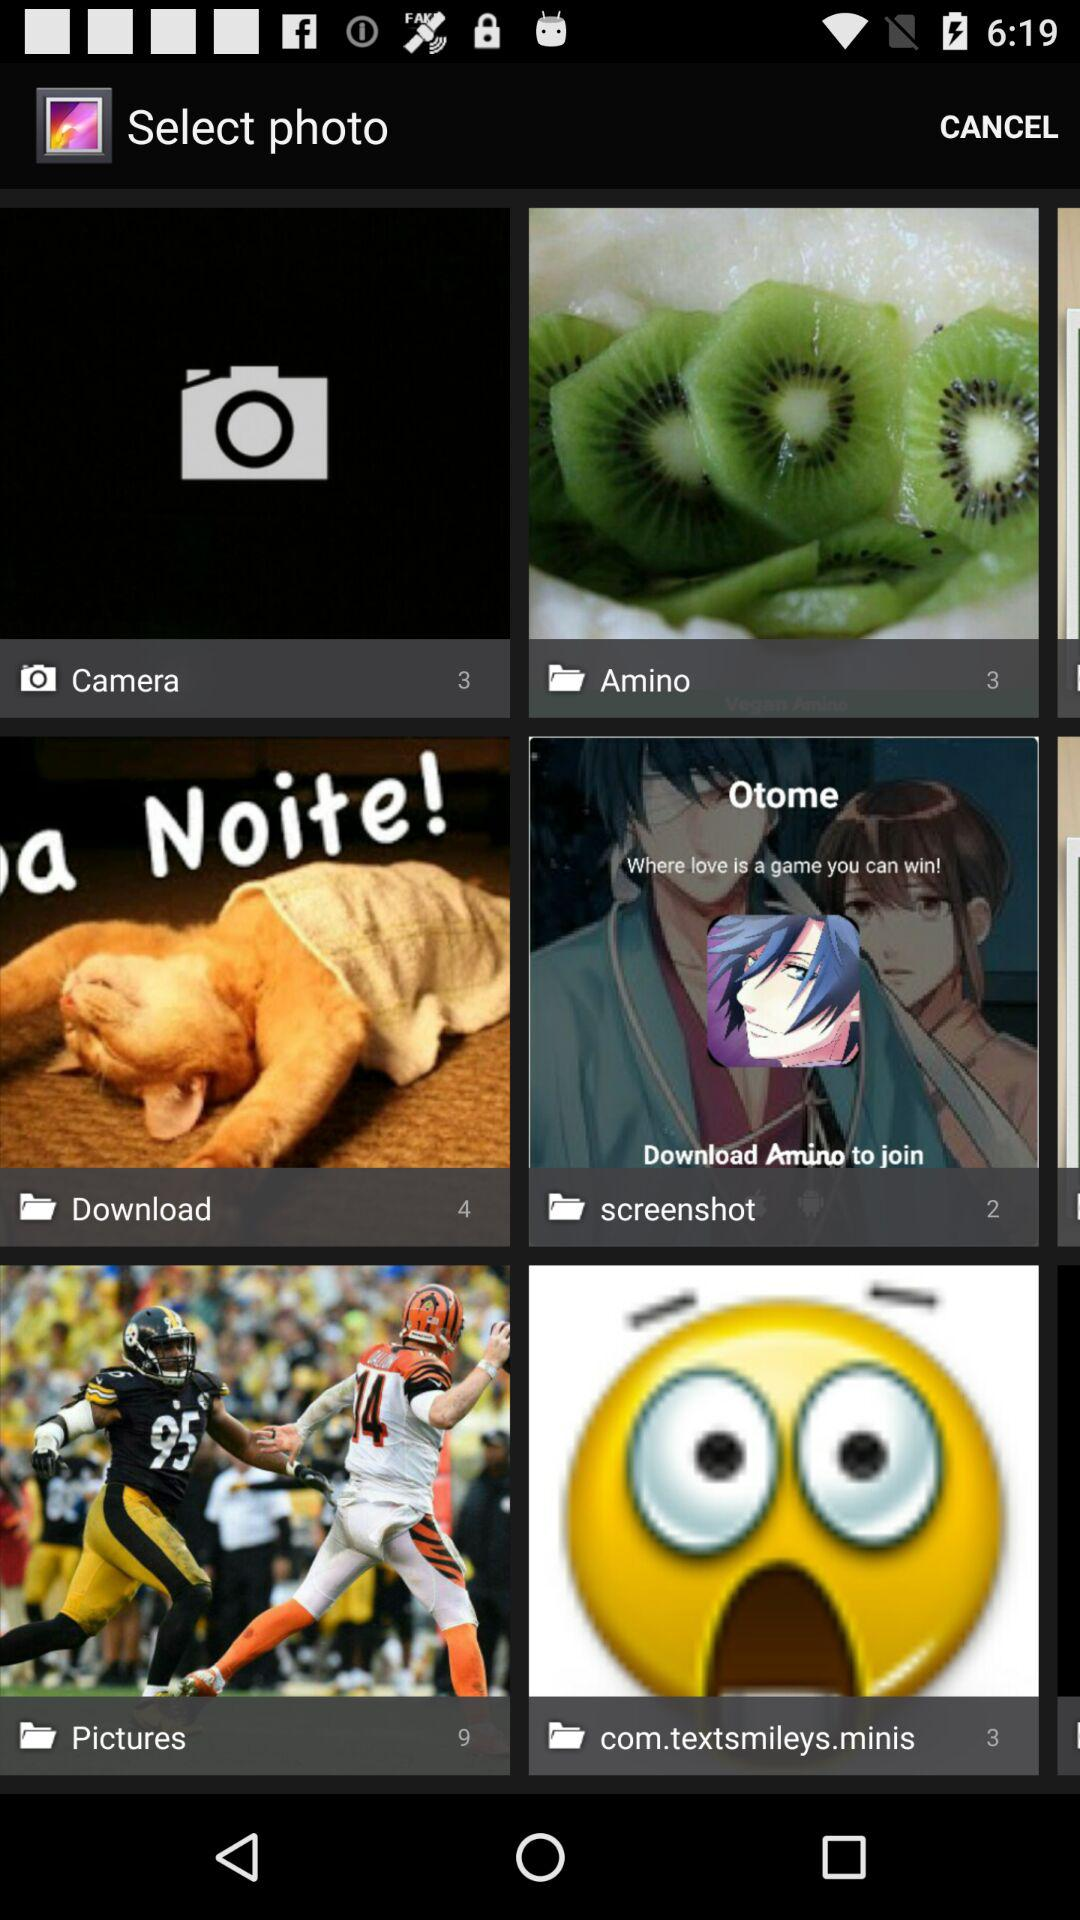Which folder has 2 photos? The folder that has 2 photos is "screenshot". 